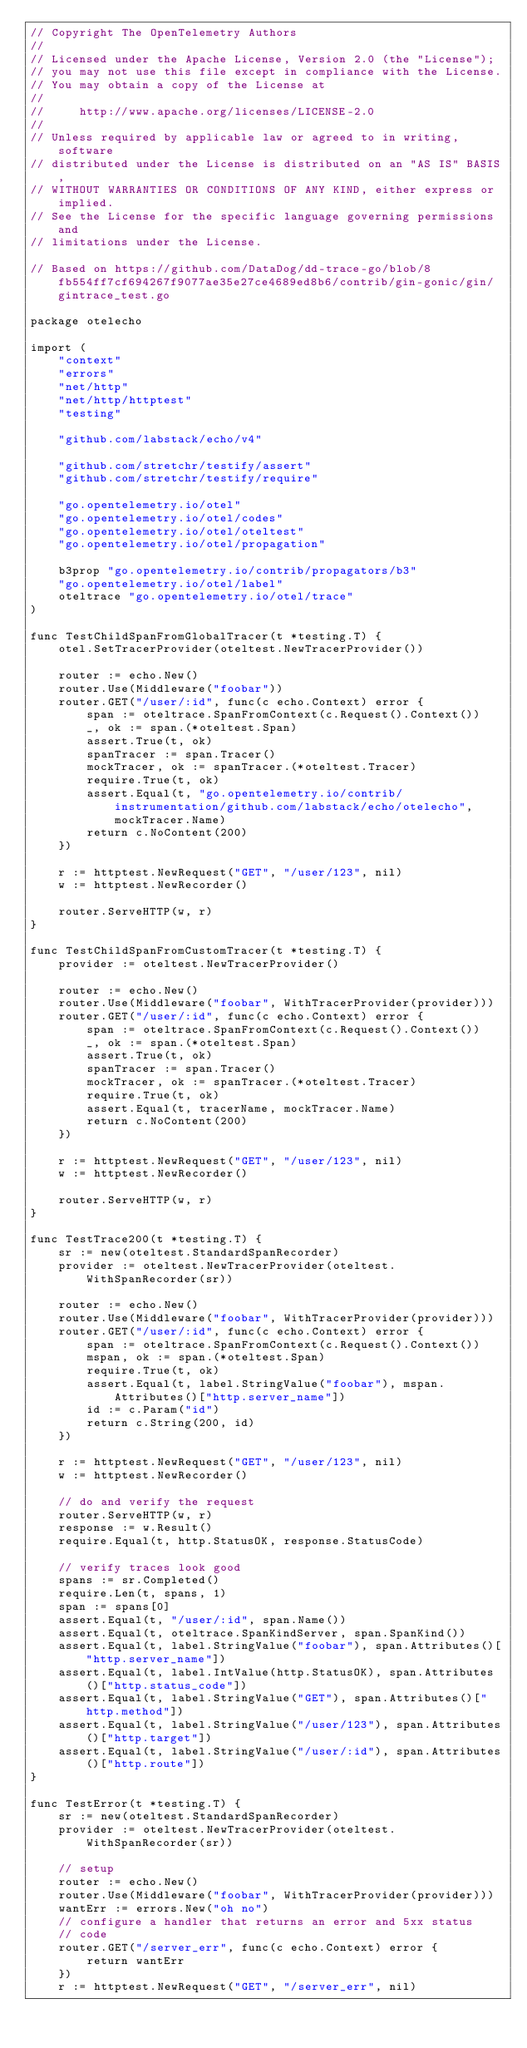Convert code to text. <code><loc_0><loc_0><loc_500><loc_500><_Go_>// Copyright The OpenTelemetry Authors
//
// Licensed under the Apache License, Version 2.0 (the "License");
// you may not use this file except in compliance with the License.
// You may obtain a copy of the License at
//
//     http://www.apache.org/licenses/LICENSE-2.0
//
// Unless required by applicable law or agreed to in writing, software
// distributed under the License is distributed on an "AS IS" BASIS,
// WITHOUT WARRANTIES OR CONDITIONS OF ANY KIND, either express or implied.
// See the License for the specific language governing permissions and
// limitations under the License.

// Based on https://github.com/DataDog/dd-trace-go/blob/8fb554ff7cf694267f9077ae35e27ce4689ed8b6/contrib/gin-gonic/gin/gintrace_test.go

package otelecho

import (
	"context"
	"errors"
	"net/http"
	"net/http/httptest"
	"testing"

	"github.com/labstack/echo/v4"

	"github.com/stretchr/testify/assert"
	"github.com/stretchr/testify/require"

	"go.opentelemetry.io/otel"
	"go.opentelemetry.io/otel/codes"
	"go.opentelemetry.io/otel/oteltest"
	"go.opentelemetry.io/otel/propagation"

	b3prop "go.opentelemetry.io/contrib/propagators/b3"
	"go.opentelemetry.io/otel/label"
	oteltrace "go.opentelemetry.io/otel/trace"
)

func TestChildSpanFromGlobalTracer(t *testing.T) {
	otel.SetTracerProvider(oteltest.NewTracerProvider())

	router := echo.New()
	router.Use(Middleware("foobar"))
	router.GET("/user/:id", func(c echo.Context) error {
		span := oteltrace.SpanFromContext(c.Request().Context())
		_, ok := span.(*oteltest.Span)
		assert.True(t, ok)
		spanTracer := span.Tracer()
		mockTracer, ok := spanTracer.(*oteltest.Tracer)
		require.True(t, ok)
		assert.Equal(t, "go.opentelemetry.io/contrib/instrumentation/github.com/labstack/echo/otelecho", mockTracer.Name)
		return c.NoContent(200)
	})

	r := httptest.NewRequest("GET", "/user/123", nil)
	w := httptest.NewRecorder()

	router.ServeHTTP(w, r)
}

func TestChildSpanFromCustomTracer(t *testing.T) {
	provider := oteltest.NewTracerProvider()

	router := echo.New()
	router.Use(Middleware("foobar", WithTracerProvider(provider)))
	router.GET("/user/:id", func(c echo.Context) error {
		span := oteltrace.SpanFromContext(c.Request().Context())
		_, ok := span.(*oteltest.Span)
		assert.True(t, ok)
		spanTracer := span.Tracer()
		mockTracer, ok := spanTracer.(*oteltest.Tracer)
		require.True(t, ok)
		assert.Equal(t, tracerName, mockTracer.Name)
		return c.NoContent(200)
	})

	r := httptest.NewRequest("GET", "/user/123", nil)
	w := httptest.NewRecorder()

	router.ServeHTTP(w, r)
}

func TestTrace200(t *testing.T) {
	sr := new(oteltest.StandardSpanRecorder)
	provider := oteltest.NewTracerProvider(oteltest.WithSpanRecorder(sr))

	router := echo.New()
	router.Use(Middleware("foobar", WithTracerProvider(provider)))
	router.GET("/user/:id", func(c echo.Context) error {
		span := oteltrace.SpanFromContext(c.Request().Context())
		mspan, ok := span.(*oteltest.Span)
		require.True(t, ok)
		assert.Equal(t, label.StringValue("foobar"), mspan.Attributes()["http.server_name"])
		id := c.Param("id")
		return c.String(200, id)
	})

	r := httptest.NewRequest("GET", "/user/123", nil)
	w := httptest.NewRecorder()

	// do and verify the request
	router.ServeHTTP(w, r)
	response := w.Result()
	require.Equal(t, http.StatusOK, response.StatusCode)

	// verify traces look good
	spans := sr.Completed()
	require.Len(t, spans, 1)
	span := spans[0]
	assert.Equal(t, "/user/:id", span.Name())
	assert.Equal(t, oteltrace.SpanKindServer, span.SpanKind())
	assert.Equal(t, label.StringValue("foobar"), span.Attributes()["http.server_name"])
	assert.Equal(t, label.IntValue(http.StatusOK), span.Attributes()["http.status_code"])
	assert.Equal(t, label.StringValue("GET"), span.Attributes()["http.method"])
	assert.Equal(t, label.StringValue("/user/123"), span.Attributes()["http.target"])
	assert.Equal(t, label.StringValue("/user/:id"), span.Attributes()["http.route"])
}

func TestError(t *testing.T) {
	sr := new(oteltest.StandardSpanRecorder)
	provider := oteltest.NewTracerProvider(oteltest.WithSpanRecorder(sr))

	// setup
	router := echo.New()
	router.Use(Middleware("foobar", WithTracerProvider(provider)))
	wantErr := errors.New("oh no")
	// configure a handler that returns an error and 5xx status
	// code
	router.GET("/server_err", func(c echo.Context) error {
		return wantErr
	})
	r := httptest.NewRequest("GET", "/server_err", nil)</code> 